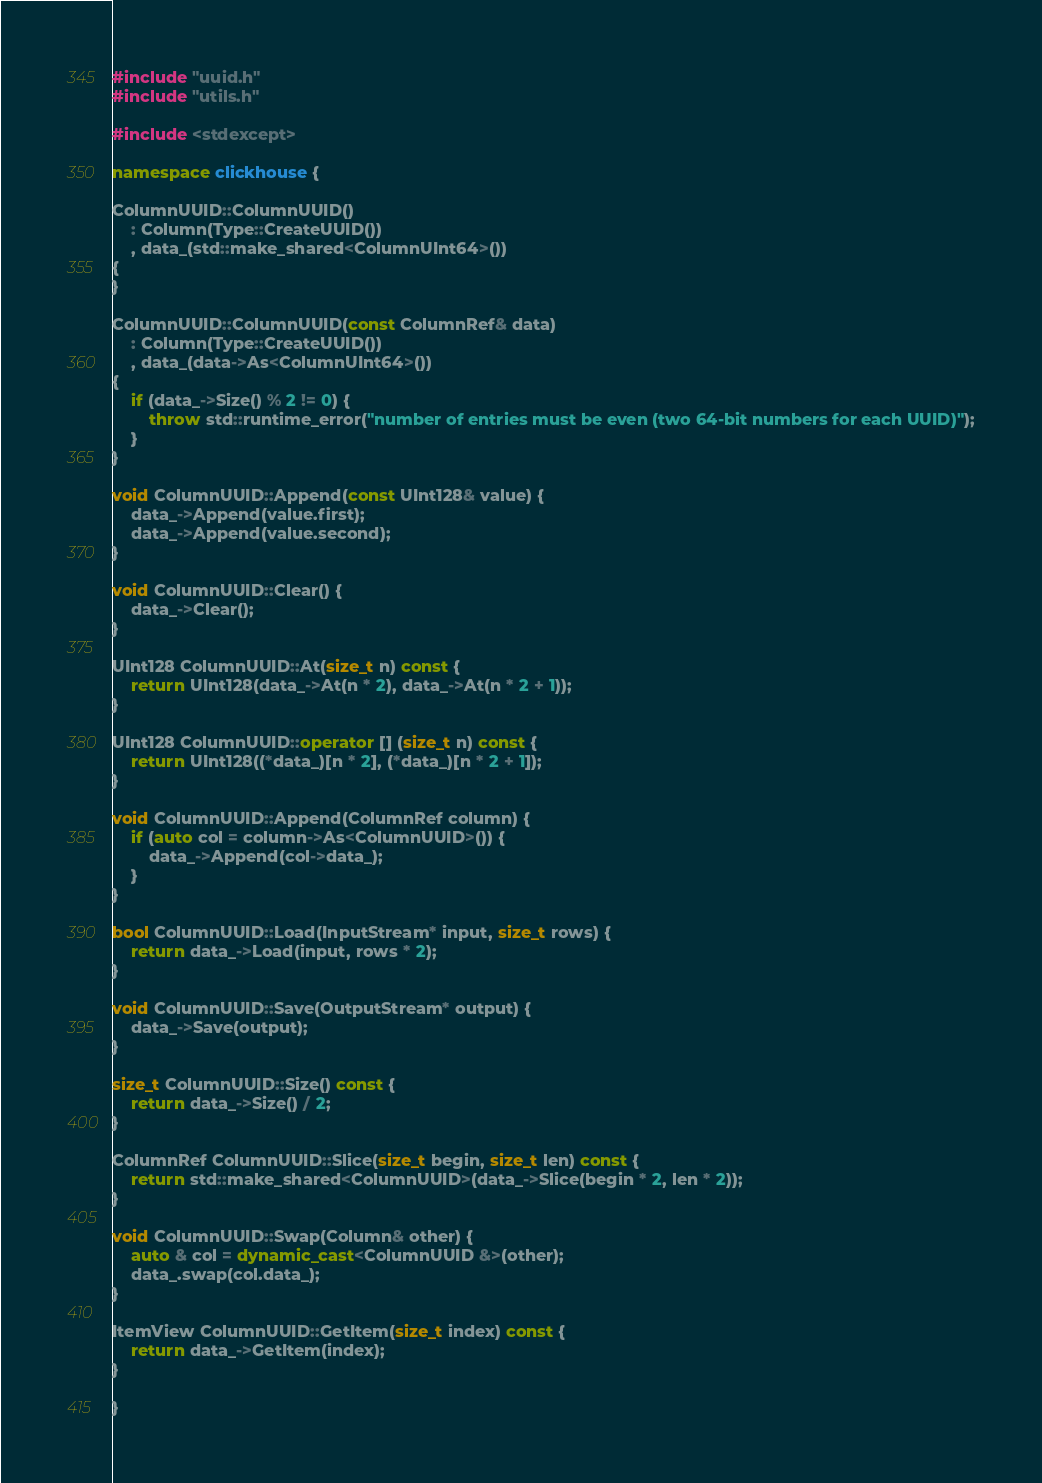<code> <loc_0><loc_0><loc_500><loc_500><_C++_>#include "uuid.h"
#include "utils.h"

#include <stdexcept>

namespace clickhouse {

ColumnUUID::ColumnUUID()
    : Column(Type::CreateUUID())
    , data_(std::make_shared<ColumnUInt64>())
{
}

ColumnUUID::ColumnUUID(const ColumnRef& data)
    : Column(Type::CreateUUID())
    , data_(data->As<ColumnUInt64>())
{
    if (data_->Size() % 2 != 0) {
        throw std::runtime_error("number of entries must be even (two 64-bit numbers for each UUID)");
    }
}

void ColumnUUID::Append(const UInt128& value) {
    data_->Append(value.first);
    data_->Append(value.second);
}

void ColumnUUID::Clear() {
    data_->Clear();
}

UInt128 ColumnUUID::At(size_t n) const {
    return UInt128(data_->At(n * 2), data_->At(n * 2 + 1));
}

UInt128 ColumnUUID::operator [] (size_t n) const {
    return UInt128((*data_)[n * 2], (*data_)[n * 2 + 1]);
}

void ColumnUUID::Append(ColumnRef column) {
    if (auto col = column->As<ColumnUUID>()) {
        data_->Append(col->data_);
    }
}

bool ColumnUUID::Load(InputStream* input, size_t rows) {
    return data_->Load(input, rows * 2);
}

void ColumnUUID::Save(OutputStream* output) {
    data_->Save(output);
}

size_t ColumnUUID::Size() const {
    return data_->Size() / 2;
}

ColumnRef ColumnUUID::Slice(size_t begin, size_t len) const {
    return std::make_shared<ColumnUUID>(data_->Slice(begin * 2, len * 2));
}

void ColumnUUID::Swap(Column& other) {
    auto & col = dynamic_cast<ColumnUUID &>(other);
    data_.swap(col.data_);
}

ItemView ColumnUUID::GetItem(size_t index) const {
    return data_->GetItem(index);
}

}

</code> 